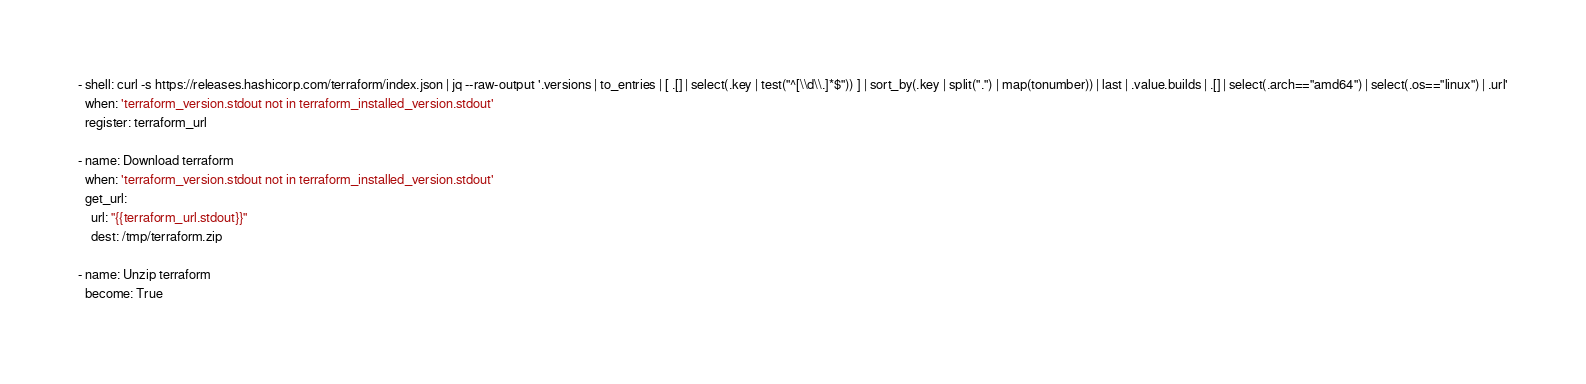Convert code to text. <code><loc_0><loc_0><loc_500><loc_500><_YAML_>- shell: curl -s https://releases.hashicorp.com/terraform/index.json | jq --raw-output '.versions | to_entries | [ .[] | select(.key | test("^[\\d\\.]*$")) ] | sort_by(.key | split(".") | map(tonumber)) | last | .value.builds | .[] | select(.arch=="amd64") | select(.os=="linux") | .url'
  when: 'terraform_version.stdout not in terraform_installed_version.stdout'
  register: terraform_url

- name: Download terraform
  when: 'terraform_version.stdout not in terraform_installed_version.stdout'
  get_url:
    url: "{{terraform_url.stdout}}"
    dest: /tmp/terraform.zip

- name: Unzip terraform
  become: True</code> 